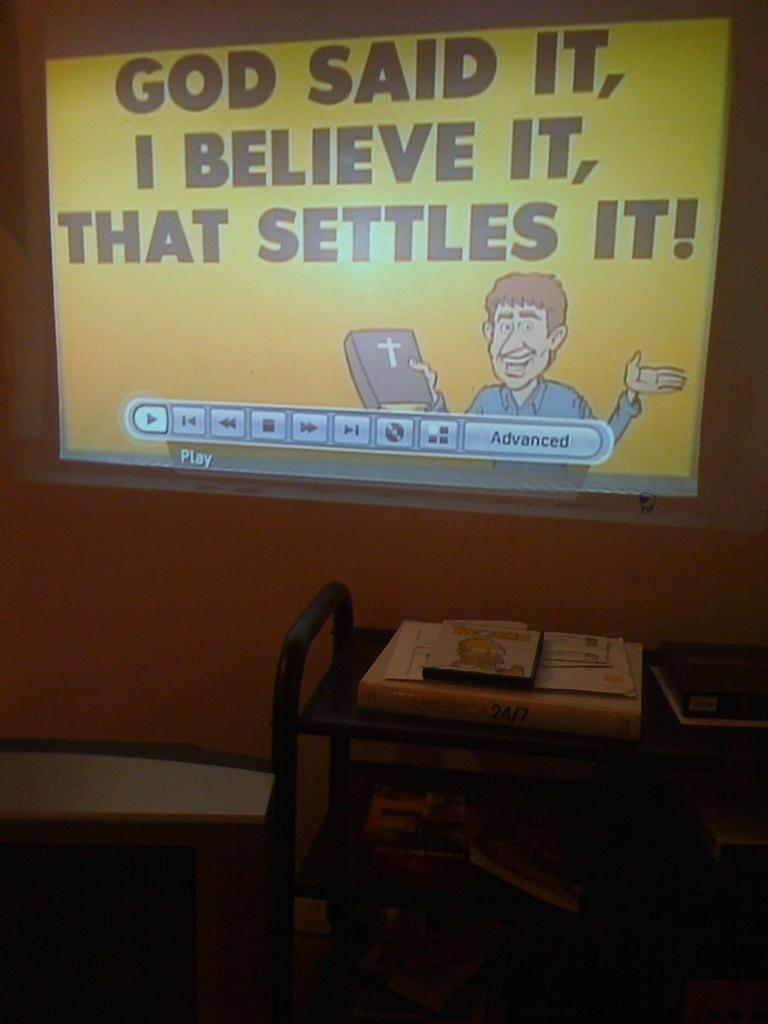What is located at the top of the image? There is a screen at the top of the image. What can be seen on the screen? The screen has some text on it. What is present at the bottom of the image? There is a table at the bottom of the image. What items are on the table? There are books on the table. How does the powder help with learning in the image? There is no powder present in the image, and therefore no such assistance can be observed. 